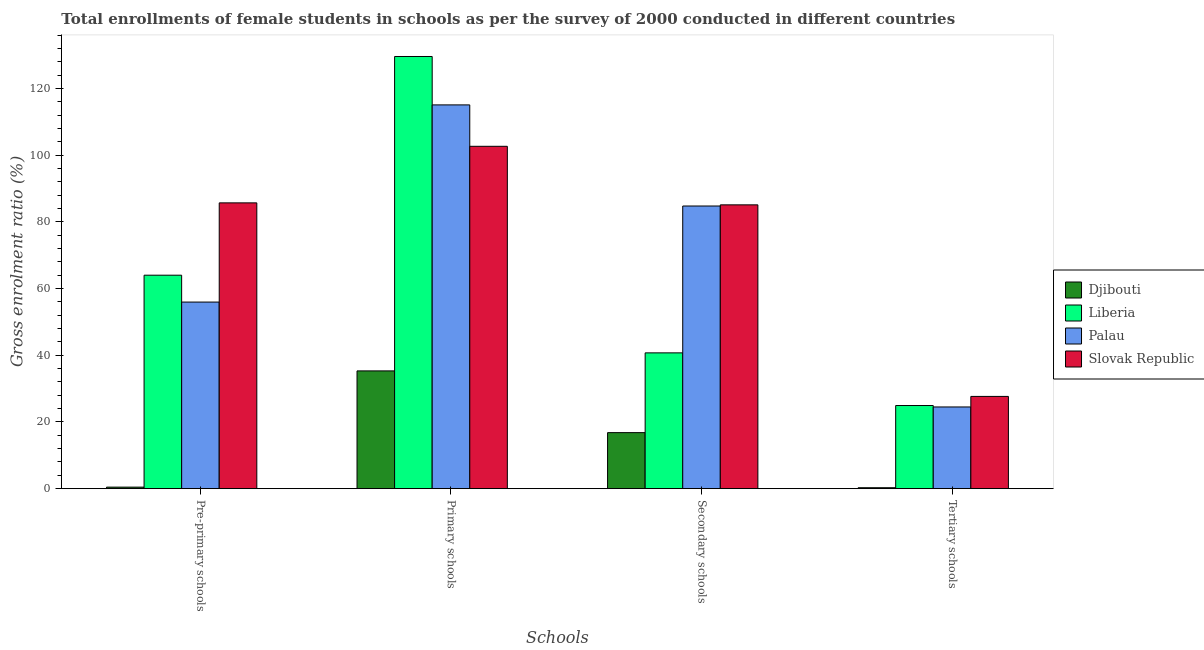How many different coloured bars are there?
Give a very brief answer. 4. Are the number of bars per tick equal to the number of legend labels?
Provide a short and direct response. Yes. What is the label of the 3rd group of bars from the left?
Your response must be concise. Secondary schools. What is the gross enrolment ratio(female) in primary schools in Palau?
Your answer should be compact. 115.08. Across all countries, what is the maximum gross enrolment ratio(female) in secondary schools?
Give a very brief answer. 85.11. Across all countries, what is the minimum gross enrolment ratio(female) in pre-primary schools?
Offer a terse response. 0.46. In which country was the gross enrolment ratio(female) in pre-primary schools maximum?
Your response must be concise. Slovak Republic. In which country was the gross enrolment ratio(female) in primary schools minimum?
Give a very brief answer. Djibouti. What is the total gross enrolment ratio(female) in secondary schools in the graph?
Your answer should be very brief. 227.39. What is the difference between the gross enrolment ratio(female) in primary schools in Palau and that in Djibouti?
Make the answer very short. 79.76. What is the difference between the gross enrolment ratio(female) in pre-primary schools in Liberia and the gross enrolment ratio(female) in secondary schools in Slovak Republic?
Provide a short and direct response. -21.09. What is the average gross enrolment ratio(female) in secondary schools per country?
Your answer should be compact. 56.85. What is the difference between the gross enrolment ratio(female) in secondary schools and gross enrolment ratio(female) in tertiary schools in Djibouti?
Your answer should be compact. 16.52. In how many countries, is the gross enrolment ratio(female) in primary schools greater than 44 %?
Keep it short and to the point. 3. What is the ratio of the gross enrolment ratio(female) in primary schools in Liberia to that in Palau?
Offer a terse response. 1.13. Is the gross enrolment ratio(female) in tertiary schools in Liberia less than that in Palau?
Provide a short and direct response. No. What is the difference between the highest and the second highest gross enrolment ratio(female) in secondary schools?
Provide a short and direct response. 0.35. What is the difference between the highest and the lowest gross enrolment ratio(female) in primary schools?
Provide a succinct answer. 94.28. Is the sum of the gross enrolment ratio(female) in tertiary schools in Djibouti and Palau greater than the maximum gross enrolment ratio(female) in pre-primary schools across all countries?
Offer a very short reply. No. Is it the case that in every country, the sum of the gross enrolment ratio(female) in primary schools and gross enrolment ratio(female) in secondary schools is greater than the sum of gross enrolment ratio(female) in pre-primary schools and gross enrolment ratio(female) in tertiary schools?
Your answer should be compact. No. What does the 4th bar from the left in Secondary schools represents?
Provide a short and direct response. Slovak Republic. What does the 2nd bar from the right in Secondary schools represents?
Provide a short and direct response. Palau. Is it the case that in every country, the sum of the gross enrolment ratio(female) in pre-primary schools and gross enrolment ratio(female) in primary schools is greater than the gross enrolment ratio(female) in secondary schools?
Your answer should be compact. Yes. How many bars are there?
Ensure brevity in your answer.  16. Are all the bars in the graph horizontal?
Keep it short and to the point. No. What is the difference between two consecutive major ticks on the Y-axis?
Your answer should be very brief. 20. Does the graph contain any zero values?
Give a very brief answer. No. Does the graph contain grids?
Your answer should be very brief. No. Where does the legend appear in the graph?
Provide a succinct answer. Center right. How are the legend labels stacked?
Give a very brief answer. Vertical. What is the title of the graph?
Provide a succinct answer. Total enrollments of female students in schools as per the survey of 2000 conducted in different countries. What is the label or title of the X-axis?
Give a very brief answer. Schools. What is the Gross enrolment ratio (%) in Djibouti in Pre-primary schools?
Make the answer very short. 0.46. What is the Gross enrolment ratio (%) in Liberia in Pre-primary schools?
Make the answer very short. 64.01. What is the Gross enrolment ratio (%) in Palau in Pre-primary schools?
Provide a succinct answer. 55.96. What is the Gross enrolment ratio (%) in Slovak Republic in Pre-primary schools?
Provide a short and direct response. 85.7. What is the Gross enrolment ratio (%) of Djibouti in Primary schools?
Your answer should be very brief. 35.32. What is the Gross enrolment ratio (%) in Liberia in Primary schools?
Provide a succinct answer. 129.6. What is the Gross enrolment ratio (%) in Palau in Primary schools?
Keep it short and to the point. 115.08. What is the Gross enrolment ratio (%) of Slovak Republic in Primary schools?
Offer a very short reply. 102.66. What is the Gross enrolment ratio (%) of Djibouti in Secondary schools?
Your response must be concise. 16.81. What is the Gross enrolment ratio (%) in Liberia in Secondary schools?
Ensure brevity in your answer.  40.72. What is the Gross enrolment ratio (%) of Palau in Secondary schools?
Provide a succinct answer. 84.76. What is the Gross enrolment ratio (%) in Slovak Republic in Secondary schools?
Offer a very short reply. 85.11. What is the Gross enrolment ratio (%) of Djibouti in Tertiary schools?
Provide a short and direct response. 0.28. What is the Gross enrolment ratio (%) of Liberia in Tertiary schools?
Give a very brief answer. 24.93. What is the Gross enrolment ratio (%) of Palau in Tertiary schools?
Make the answer very short. 24.5. What is the Gross enrolment ratio (%) of Slovak Republic in Tertiary schools?
Make the answer very short. 27.67. Across all Schools, what is the maximum Gross enrolment ratio (%) of Djibouti?
Offer a very short reply. 35.32. Across all Schools, what is the maximum Gross enrolment ratio (%) in Liberia?
Provide a succinct answer. 129.6. Across all Schools, what is the maximum Gross enrolment ratio (%) in Palau?
Your answer should be very brief. 115.08. Across all Schools, what is the maximum Gross enrolment ratio (%) in Slovak Republic?
Keep it short and to the point. 102.66. Across all Schools, what is the minimum Gross enrolment ratio (%) in Djibouti?
Your answer should be very brief. 0.28. Across all Schools, what is the minimum Gross enrolment ratio (%) in Liberia?
Make the answer very short. 24.93. Across all Schools, what is the minimum Gross enrolment ratio (%) of Palau?
Give a very brief answer. 24.5. Across all Schools, what is the minimum Gross enrolment ratio (%) of Slovak Republic?
Provide a short and direct response. 27.67. What is the total Gross enrolment ratio (%) of Djibouti in the graph?
Offer a very short reply. 52.86. What is the total Gross enrolment ratio (%) of Liberia in the graph?
Make the answer very short. 259.27. What is the total Gross enrolment ratio (%) in Palau in the graph?
Provide a succinct answer. 280.3. What is the total Gross enrolment ratio (%) of Slovak Republic in the graph?
Your response must be concise. 301.14. What is the difference between the Gross enrolment ratio (%) of Djibouti in Pre-primary schools and that in Primary schools?
Your answer should be compact. -34.85. What is the difference between the Gross enrolment ratio (%) in Liberia in Pre-primary schools and that in Primary schools?
Offer a very short reply. -65.58. What is the difference between the Gross enrolment ratio (%) of Palau in Pre-primary schools and that in Primary schools?
Provide a succinct answer. -59.12. What is the difference between the Gross enrolment ratio (%) of Slovak Republic in Pre-primary schools and that in Primary schools?
Your response must be concise. -16.96. What is the difference between the Gross enrolment ratio (%) of Djibouti in Pre-primary schools and that in Secondary schools?
Ensure brevity in your answer.  -16.34. What is the difference between the Gross enrolment ratio (%) of Liberia in Pre-primary schools and that in Secondary schools?
Provide a short and direct response. 23.29. What is the difference between the Gross enrolment ratio (%) in Palau in Pre-primary schools and that in Secondary schools?
Provide a short and direct response. -28.8. What is the difference between the Gross enrolment ratio (%) of Slovak Republic in Pre-primary schools and that in Secondary schools?
Offer a very short reply. 0.59. What is the difference between the Gross enrolment ratio (%) in Djibouti in Pre-primary schools and that in Tertiary schools?
Offer a very short reply. 0.18. What is the difference between the Gross enrolment ratio (%) of Liberia in Pre-primary schools and that in Tertiary schools?
Make the answer very short. 39.08. What is the difference between the Gross enrolment ratio (%) in Palau in Pre-primary schools and that in Tertiary schools?
Keep it short and to the point. 31.45. What is the difference between the Gross enrolment ratio (%) of Slovak Republic in Pre-primary schools and that in Tertiary schools?
Give a very brief answer. 58.03. What is the difference between the Gross enrolment ratio (%) in Djibouti in Primary schools and that in Secondary schools?
Ensure brevity in your answer.  18.51. What is the difference between the Gross enrolment ratio (%) of Liberia in Primary schools and that in Secondary schools?
Your answer should be compact. 88.87. What is the difference between the Gross enrolment ratio (%) in Palau in Primary schools and that in Secondary schools?
Make the answer very short. 30.32. What is the difference between the Gross enrolment ratio (%) of Slovak Republic in Primary schools and that in Secondary schools?
Make the answer very short. 17.56. What is the difference between the Gross enrolment ratio (%) in Djibouti in Primary schools and that in Tertiary schools?
Your answer should be very brief. 35.03. What is the difference between the Gross enrolment ratio (%) of Liberia in Primary schools and that in Tertiary schools?
Provide a succinct answer. 104.66. What is the difference between the Gross enrolment ratio (%) of Palau in Primary schools and that in Tertiary schools?
Provide a short and direct response. 90.58. What is the difference between the Gross enrolment ratio (%) in Slovak Republic in Primary schools and that in Tertiary schools?
Offer a very short reply. 75. What is the difference between the Gross enrolment ratio (%) of Djibouti in Secondary schools and that in Tertiary schools?
Provide a short and direct response. 16.52. What is the difference between the Gross enrolment ratio (%) in Liberia in Secondary schools and that in Tertiary schools?
Keep it short and to the point. 15.79. What is the difference between the Gross enrolment ratio (%) of Palau in Secondary schools and that in Tertiary schools?
Make the answer very short. 60.26. What is the difference between the Gross enrolment ratio (%) of Slovak Republic in Secondary schools and that in Tertiary schools?
Offer a terse response. 57.44. What is the difference between the Gross enrolment ratio (%) in Djibouti in Pre-primary schools and the Gross enrolment ratio (%) in Liberia in Primary schools?
Provide a succinct answer. -129.14. What is the difference between the Gross enrolment ratio (%) in Djibouti in Pre-primary schools and the Gross enrolment ratio (%) in Palau in Primary schools?
Ensure brevity in your answer.  -114.62. What is the difference between the Gross enrolment ratio (%) in Djibouti in Pre-primary schools and the Gross enrolment ratio (%) in Slovak Republic in Primary schools?
Your answer should be very brief. -102.2. What is the difference between the Gross enrolment ratio (%) of Liberia in Pre-primary schools and the Gross enrolment ratio (%) of Palau in Primary schools?
Provide a short and direct response. -51.07. What is the difference between the Gross enrolment ratio (%) of Liberia in Pre-primary schools and the Gross enrolment ratio (%) of Slovak Republic in Primary schools?
Provide a succinct answer. -38.65. What is the difference between the Gross enrolment ratio (%) in Palau in Pre-primary schools and the Gross enrolment ratio (%) in Slovak Republic in Primary schools?
Your response must be concise. -46.71. What is the difference between the Gross enrolment ratio (%) of Djibouti in Pre-primary schools and the Gross enrolment ratio (%) of Liberia in Secondary schools?
Offer a very short reply. -40.26. What is the difference between the Gross enrolment ratio (%) of Djibouti in Pre-primary schools and the Gross enrolment ratio (%) of Palau in Secondary schools?
Your answer should be compact. -84.3. What is the difference between the Gross enrolment ratio (%) of Djibouti in Pre-primary schools and the Gross enrolment ratio (%) of Slovak Republic in Secondary schools?
Make the answer very short. -84.64. What is the difference between the Gross enrolment ratio (%) of Liberia in Pre-primary schools and the Gross enrolment ratio (%) of Palau in Secondary schools?
Offer a terse response. -20.75. What is the difference between the Gross enrolment ratio (%) of Liberia in Pre-primary schools and the Gross enrolment ratio (%) of Slovak Republic in Secondary schools?
Your answer should be compact. -21.09. What is the difference between the Gross enrolment ratio (%) of Palau in Pre-primary schools and the Gross enrolment ratio (%) of Slovak Republic in Secondary schools?
Your response must be concise. -29.15. What is the difference between the Gross enrolment ratio (%) in Djibouti in Pre-primary schools and the Gross enrolment ratio (%) in Liberia in Tertiary schools?
Keep it short and to the point. -24.47. What is the difference between the Gross enrolment ratio (%) in Djibouti in Pre-primary schools and the Gross enrolment ratio (%) in Palau in Tertiary schools?
Your response must be concise. -24.04. What is the difference between the Gross enrolment ratio (%) of Djibouti in Pre-primary schools and the Gross enrolment ratio (%) of Slovak Republic in Tertiary schools?
Make the answer very short. -27.2. What is the difference between the Gross enrolment ratio (%) of Liberia in Pre-primary schools and the Gross enrolment ratio (%) of Palau in Tertiary schools?
Make the answer very short. 39.51. What is the difference between the Gross enrolment ratio (%) of Liberia in Pre-primary schools and the Gross enrolment ratio (%) of Slovak Republic in Tertiary schools?
Offer a terse response. 36.35. What is the difference between the Gross enrolment ratio (%) in Palau in Pre-primary schools and the Gross enrolment ratio (%) in Slovak Republic in Tertiary schools?
Make the answer very short. 28.29. What is the difference between the Gross enrolment ratio (%) in Djibouti in Primary schools and the Gross enrolment ratio (%) in Liberia in Secondary schools?
Give a very brief answer. -5.41. What is the difference between the Gross enrolment ratio (%) of Djibouti in Primary schools and the Gross enrolment ratio (%) of Palau in Secondary schools?
Your answer should be compact. -49.44. What is the difference between the Gross enrolment ratio (%) of Djibouti in Primary schools and the Gross enrolment ratio (%) of Slovak Republic in Secondary schools?
Offer a terse response. -49.79. What is the difference between the Gross enrolment ratio (%) in Liberia in Primary schools and the Gross enrolment ratio (%) in Palau in Secondary schools?
Your answer should be very brief. 44.84. What is the difference between the Gross enrolment ratio (%) in Liberia in Primary schools and the Gross enrolment ratio (%) in Slovak Republic in Secondary schools?
Provide a succinct answer. 44.49. What is the difference between the Gross enrolment ratio (%) of Palau in Primary schools and the Gross enrolment ratio (%) of Slovak Republic in Secondary schools?
Give a very brief answer. 29.97. What is the difference between the Gross enrolment ratio (%) of Djibouti in Primary schools and the Gross enrolment ratio (%) of Liberia in Tertiary schools?
Keep it short and to the point. 10.38. What is the difference between the Gross enrolment ratio (%) of Djibouti in Primary schools and the Gross enrolment ratio (%) of Palau in Tertiary schools?
Your answer should be compact. 10.81. What is the difference between the Gross enrolment ratio (%) of Djibouti in Primary schools and the Gross enrolment ratio (%) of Slovak Republic in Tertiary schools?
Ensure brevity in your answer.  7.65. What is the difference between the Gross enrolment ratio (%) in Liberia in Primary schools and the Gross enrolment ratio (%) in Palau in Tertiary schools?
Provide a succinct answer. 105.09. What is the difference between the Gross enrolment ratio (%) of Liberia in Primary schools and the Gross enrolment ratio (%) of Slovak Republic in Tertiary schools?
Provide a short and direct response. 101.93. What is the difference between the Gross enrolment ratio (%) in Palau in Primary schools and the Gross enrolment ratio (%) in Slovak Republic in Tertiary schools?
Keep it short and to the point. 87.41. What is the difference between the Gross enrolment ratio (%) of Djibouti in Secondary schools and the Gross enrolment ratio (%) of Liberia in Tertiary schools?
Your answer should be very brief. -8.13. What is the difference between the Gross enrolment ratio (%) in Djibouti in Secondary schools and the Gross enrolment ratio (%) in Palau in Tertiary schools?
Provide a succinct answer. -7.7. What is the difference between the Gross enrolment ratio (%) in Djibouti in Secondary schools and the Gross enrolment ratio (%) in Slovak Republic in Tertiary schools?
Give a very brief answer. -10.86. What is the difference between the Gross enrolment ratio (%) of Liberia in Secondary schools and the Gross enrolment ratio (%) of Palau in Tertiary schools?
Your response must be concise. 16.22. What is the difference between the Gross enrolment ratio (%) of Liberia in Secondary schools and the Gross enrolment ratio (%) of Slovak Republic in Tertiary schools?
Make the answer very short. 13.06. What is the difference between the Gross enrolment ratio (%) of Palau in Secondary schools and the Gross enrolment ratio (%) of Slovak Republic in Tertiary schools?
Your answer should be compact. 57.09. What is the average Gross enrolment ratio (%) of Djibouti per Schools?
Your answer should be very brief. 13.22. What is the average Gross enrolment ratio (%) in Liberia per Schools?
Provide a short and direct response. 64.82. What is the average Gross enrolment ratio (%) of Palau per Schools?
Ensure brevity in your answer.  70.07. What is the average Gross enrolment ratio (%) in Slovak Republic per Schools?
Your answer should be compact. 75.28. What is the difference between the Gross enrolment ratio (%) of Djibouti and Gross enrolment ratio (%) of Liberia in Pre-primary schools?
Keep it short and to the point. -63.55. What is the difference between the Gross enrolment ratio (%) of Djibouti and Gross enrolment ratio (%) of Palau in Pre-primary schools?
Provide a short and direct response. -55.5. What is the difference between the Gross enrolment ratio (%) of Djibouti and Gross enrolment ratio (%) of Slovak Republic in Pre-primary schools?
Provide a succinct answer. -85.24. What is the difference between the Gross enrolment ratio (%) of Liberia and Gross enrolment ratio (%) of Palau in Pre-primary schools?
Give a very brief answer. 8.06. What is the difference between the Gross enrolment ratio (%) in Liberia and Gross enrolment ratio (%) in Slovak Republic in Pre-primary schools?
Your answer should be compact. -21.69. What is the difference between the Gross enrolment ratio (%) in Palau and Gross enrolment ratio (%) in Slovak Republic in Pre-primary schools?
Keep it short and to the point. -29.74. What is the difference between the Gross enrolment ratio (%) in Djibouti and Gross enrolment ratio (%) in Liberia in Primary schools?
Keep it short and to the point. -94.28. What is the difference between the Gross enrolment ratio (%) of Djibouti and Gross enrolment ratio (%) of Palau in Primary schools?
Keep it short and to the point. -79.76. What is the difference between the Gross enrolment ratio (%) in Djibouti and Gross enrolment ratio (%) in Slovak Republic in Primary schools?
Ensure brevity in your answer.  -67.35. What is the difference between the Gross enrolment ratio (%) in Liberia and Gross enrolment ratio (%) in Palau in Primary schools?
Offer a very short reply. 14.52. What is the difference between the Gross enrolment ratio (%) in Liberia and Gross enrolment ratio (%) in Slovak Republic in Primary schools?
Offer a very short reply. 26.93. What is the difference between the Gross enrolment ratio (%) in Palau and Gross enrolment ratio (%) in Slovak Republic in Primary schools?
Your response must be concise. 12.42. What is the difference between the Gross enrolment ratio (%) in Djibouti and Gross enrolment ratio (%) in Liberia in Secondary schools?
Keep it short and to the point. -23.92. What is the difference between the Gross enrolment ratio (%) in Djibouti and Gross enrolment ratio (%) in Palau in Secondary schools?
Give a very brief answer. -67.95. What is the difference between the Gross enrolment ratio (%) in Djibouti and Gross enrolment ratio (%) in Slovak Republic in Secondary schools?
Offer a terse response. -68.3. What is the difference between the Gross enrolment ratio (%) of Liberia and Gross enrolment ratio (%) of Palau in Secondary schools?
Your answer should be very brief. -44.04. What is the difference between the Gross enrolment ratio (%) of Liberia and Gross enrolment ratio (%) of Slovak Republic in Secondary schools?
Your answer should be very brief. -44.38. What is the difference between the Gross enrolment ratio (%) of Palau and Gross enrolment ratio (%) of Slovak Republic in Secondary schools?
Ensure brevity in your answer.  -0.35. What is the difference between the Gross enrolment ratio (%) of Djibouti and Gross enrolment ratio (%) of Liberia in Tertiary schools?
Your answer should be very brief. -24.65. What is the difference between the Gross enrolment ratio (%) of Djibouti and Gross enrolment ratio (%) of Palau in Tertiary schools?
Offer a very short reply. -24.22. What is the difference between the Gross enrolment ratio (%) in Djibouti and Gross enrolment ratio (%) in Slovak Republic in Tertiary schools?
Offer a terse response. -27.38. What is the difference between the Gross enrolment ratio (%) in Liberia and Gross enrolment ratio (%) in Palau in Tertiary schools?
Ensure brevity in your answer.  0.43. What is the difference between the Gross enrolment ratio (%) of Liberia and Gross enrolment ratio (%) of Slovak Republic in Tertiary schools?
Your response must be concise. -2.73. What is the difference between the Gross enrolment ratio (%) in Palau and Gross enrolment ratio (%) in Slovak Republic in Tertiary schools?
Your answer should be very brief. -3.16. What is the ratio of the Gross enrolment ratio (%) in Djibouti in Pre-primary schools to that in Primary schools?
Offer a terse response. 0.01. What is the ratio of the Gross enrolment ratio (%) of Liberia in Pre-primary schools to that in Primary schools?
Provide a short and direct response. 0.49. What is the ratio of the Gross enrolment ratio (%) of Palau in Pre-primary schools to that in Primary schools?
Give a very brief answer. 0.49. What is the ratio of the Gross enrolment ratio (%) in Slovak Republic in Pre-primary schools to that in Primary schools?
Keep it short and to the point. 0.83. What is the ratio of the Gross enrolment ratio (%) in Djibouti in Pre-primary schools to that in Secondary schools?
Keep it short and to the point. 0.03. What is the ratio of the Gross enrolment ratio (%) of Liberia in Pre-primary schools to that in Secondary schools?
Offer a very short reply. 1.57. What is the ratio of the Gross enrolment ratio (%) of Palau in Pre-primary schools to that in Secondary schools?
Provide a succinct answer. 0.66. What is the ratio of the Gross enrolment ratio (%) of Djibouti in Pre-primary schools to that in Tertiary schools?
Your answer should be compact. 1.63. What is the ratio of the Gross enrolment ratio (%) in Liberia in Pre-primary schools to that in Tertiary schools?
Provide a short and direct response. 2.57. What is the ratio of the Gross enrolment ratio (%) of Palau in Pre-primary schools to that in Tertiary schools?
Your response must be concise. 2.28. What is the ratio of the Gross enrolment ratio (%) in Slovak Republic in Pre-primary schools to that in Tertiary schools?
Offer a terse response. 3.1. What is the ratio of the Gross enrolment ratio (%) of Djibouti in Primary schools to that in Secondary schools?
Ensure brevity in your answer.  2.1. What is the ratio of the Gross enrolment ratio (%) of Liberia in Primary schools to that in Secondary schools?
Give a very brief answer. 3.18. What is the ratio of the Gross enrolment ratio (%) in Palau in Primary schools to that in Secondary schools?
Your answer should be compact. 1.36. What is the ratio of the Gross enrolment ratio (%) in Slovak Republic in Primary schools to that in Secondary schools?
Your answer should be compact. 1.21. What is the ratio of the Gross enrolment ratio (%) of Djibouti in Primary schools to that in Tertiary schools?
Your response must be concise. 125.05. What is the ratio of the Gross enrolment ratio (%) of Liberia in Primary schools to that in Tertiary schools?
Keep it short and to the point. 5.2. What is the ratio of the Gross enrolment ratio (%) of Palau in Primary schools to that in Tertiary schools?
Offer a very short reply. 4.7. What is the ratio of the Gross enrolment ratio (%) in Slovak Republic in Primary schools to that in Tertiary schools?
Your response must be concise. 3.71. What is the ratio of the Gross enrolment ratio (%) of Djibouti in Secondary schools to that in Tertiary schools?
Keep it short and to the point. 59.51. What is the ratio of the Gross enrolment ratio (%) in Liberia in Secondary schools to that in Tertiary schools?
Make the answer very short. 1.63. What is the ratio of the Gross enrolment ratio (%) in Palau in Secondary schools to that in Tertiary schools?
Your response must be concise. 3.46. What is the ratio of the Gross enrolment ratio (%) of Slovak Republic in Secondary schools to that in Tertiary schools?
Offer a very short reply. 3.08. What is the difference between the highest and the second highest Gross enrolment ratio (%) of Djibouti?
Offer a very short reply. 18.51. What is the difference between the highest and the second highest Gross enrolment ratio (%) in Liberia?
Provide a short and direct response. 65.58. What is the difference between the highest and the second highest Gross enrolment ratio (%) of Palau?
Provide a short and direct response. 30.32. What is the difference between the highest and the second highest Gross enrolment ratio (%) of Slovak Republic?
Offer a very short reply. 16.96. What is the difference between the highest and the lowest Gross enrolment ratio (%) of Djibouti?
Keep it short and to the point. 35.03. What is the difference between the highest and the lowest Gross enrolment ratio (%) in Liberia?
Your answer should be compact. 104.66. What is the difference between the highest and the lowest Gross enrolment ratio (%) of Palau?
Keep it short and to the point. 90.58. What is the difference between the highest and the lowest Gross enrolment ratio (%) of Slovak Republic?
Offer a terse response. 75. 